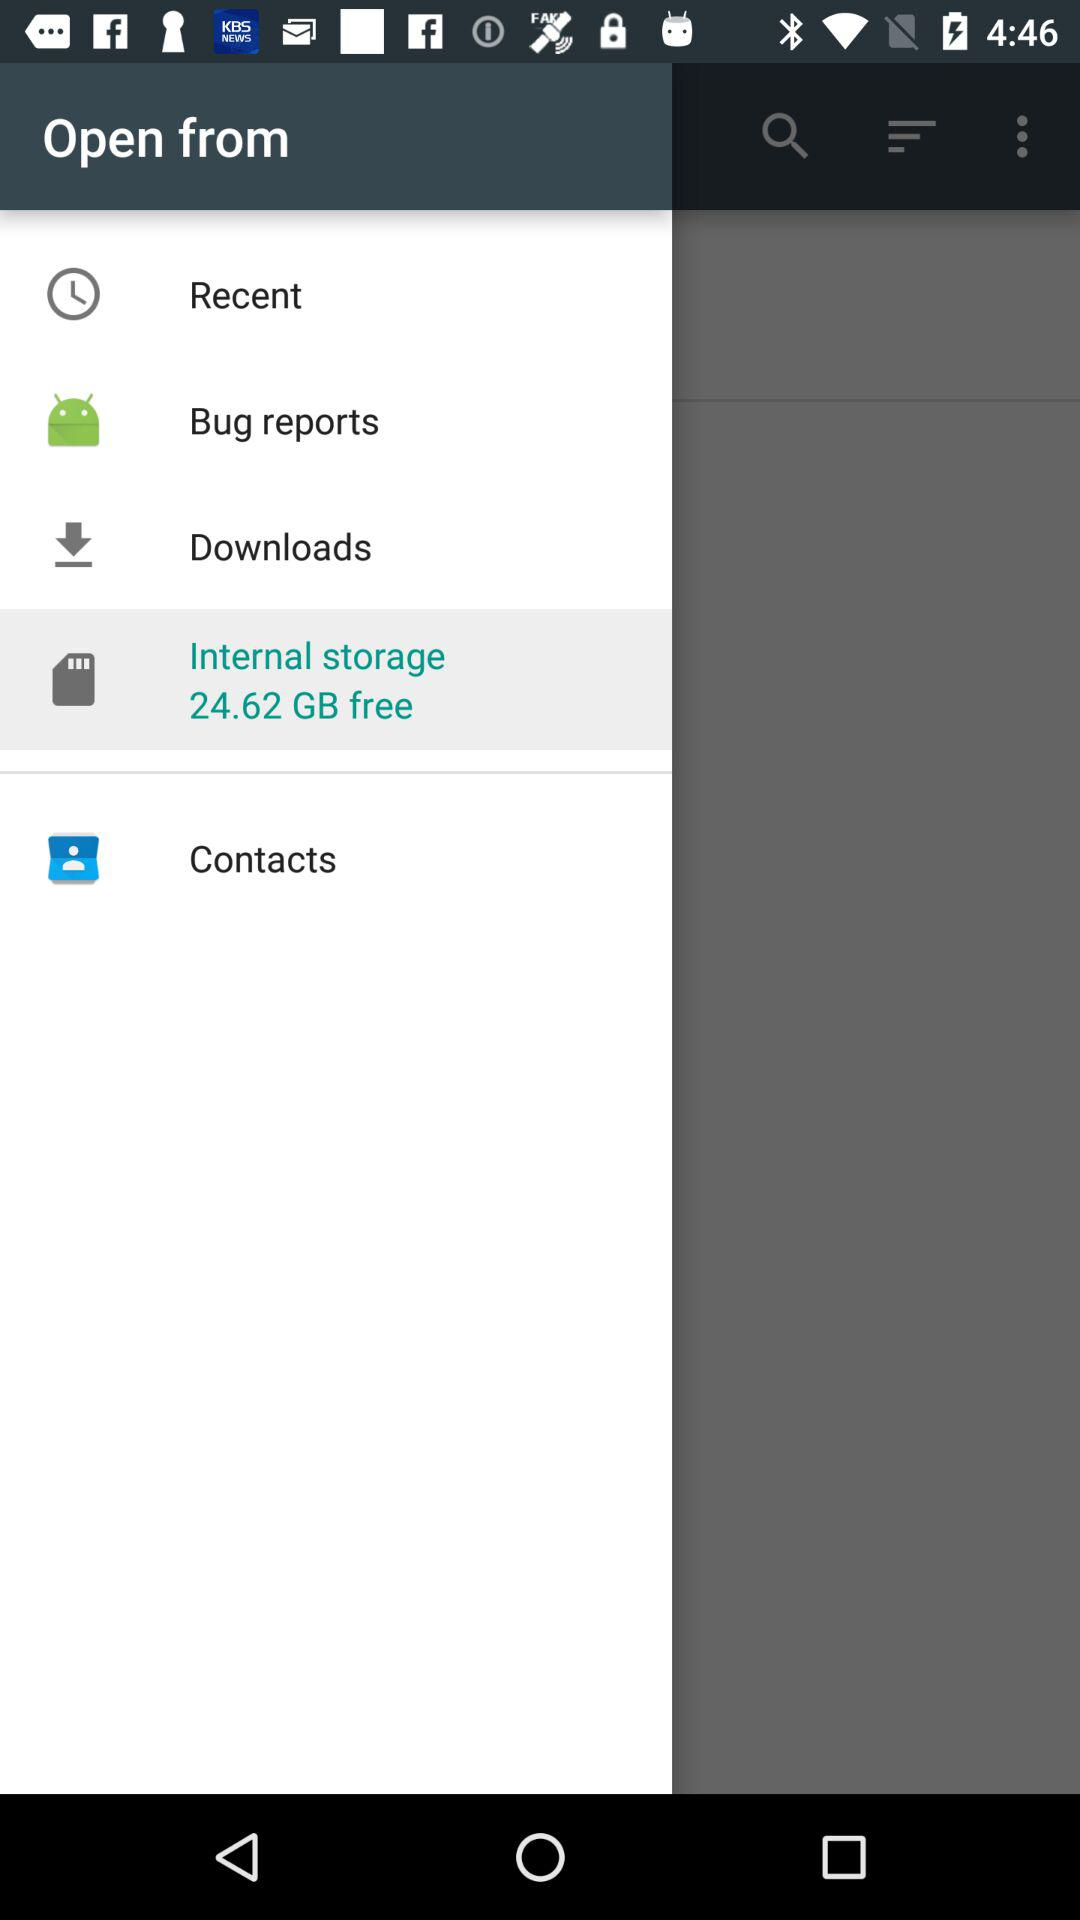How many more gigabytes of free storage do I have than the amount of storage used by downloads?
Answer the question using a single word or phrase. 24.62 